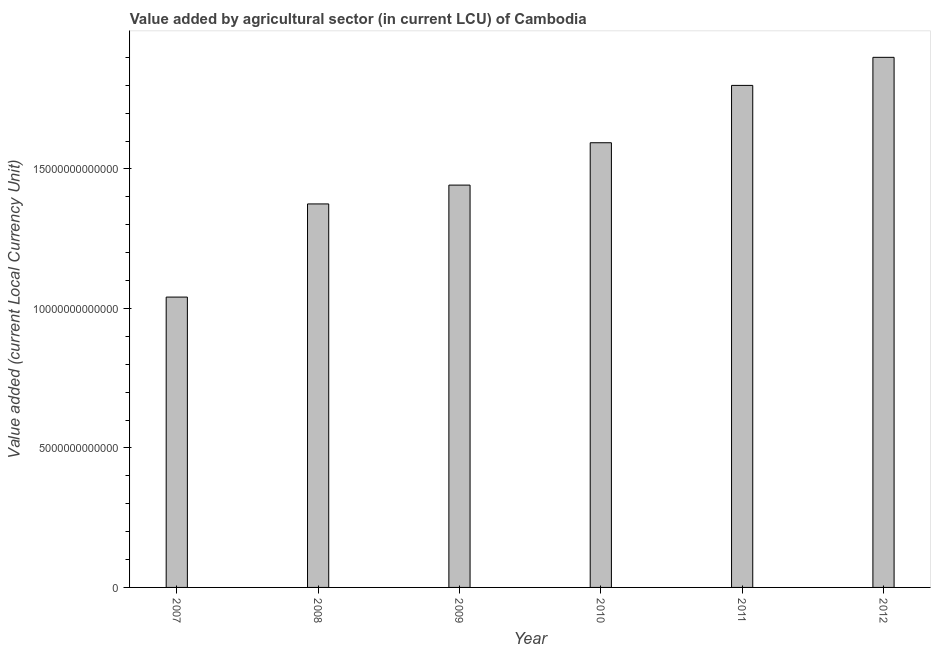Does the graph contain any zero values?
Your response must be concise. No. What is the title of the graph?
Give a very brief answer. Value added by agricultural sector (in current LCU) of Cambodia. What is the label or title of the Y-axis?
Provide a succinct answer. Value added (current Local Currency Unit). What is the value added by agriculture sector in 2011?
Your answer should be very brief. 1.80e+13. Across all years, what is the maximum value added by agriculture sector?
Offer a terse response. 1.90e+13. Across all years, what is the minimum value added by agriculture sector?
Provide a succinct answer. 1.04e+13. In which year was the value added by agriculture sector minimum?
Your answer should be very brief. 2007. What is the sum of the value added by agriculture sector?
Keep it short and to the point. 9.15e+13. What is the difference between the value added by agriculture sector in 2010 and 2011?
Your response must be concise. -2.06e+12. What is the average value added by agriculture sector per year?
Ensure brevity in your answer.  1.53e+13. What is the median value added by agriculture sector?
Provide a succinct answer. 1.52e+13. In how many years, is the value added by agriculture sector greater than 5000000000000 LCU?
Offer a very short reply. 6. Do a majority of the years between 2009 and 2007 (inclusive) have value added by agriculture sector greater than 14000000000000 LCU?
Your response must be concise. Yes. What is the ratio of the value added by agriculture sector in 2010 to that in 2011?
Provide a short and direct response. 0.89. Is the difference between the value added by agriculture sector in 2010 and 2011 greater than the difference between any two years?
Offer a very short reply. No. What is the difference between the highest and the second highest value added by agriculture sector?
Offer a terse response. 1.01e+12. What is the difference between the highest and the lowest value added by agriculture sector?
Your answer should be compact. 8.59e+12. How many bars are there?
Provide a short and direct response. 6. What is the difference between two consecutive major ticks on the Y-axis?
Provide a succinct answer. 5.00e+12. What is the Value added (current Local Currency Unit) of 2007?
Provide a short and direct response. 1.04e+13. What is the Value added (current Local Currency Unit) of 2008?
Keep it short and to the point. 1.37e+13. What is the Value added (current Local Currency Unit) in 2009?
Provide a short and direct response. 1.44e+13. What is the Value added (current Local Currency Unit) in 2010?
Your answer should be compact. 1.59e+13. What is the Value added (current Local Currency Unit) in 2011?
Provide a short and direct response. 1.80e+13. What is the Value added (current Local Currency Unit) in 2012?
Ensure brevity in your answer.  1.90e+13. What is the difference between the Value added (current Local Currency Unit) in 2007 and 2008?
Your answer should be compact. -3.34e+12. What is the difference between the Value added (current Local Currency Unit) in 2007 and 2009?
Provide a succinct answer. -4.01e+12. What is the difference between the Value added (current Local Currency Unit) in 2007 and 2010?
Keep it short and to the point. -5.53e+12. What is the difference between the Value added (current Local Currency Unit) in 2007 and 2011?
Make the answer very short. -7.59e+12. What is the difference between the Value added (current Local Currency Unit) in 2007 and 2012?
Your answer should be very brief. -8.59e+12. What is the difference between the Value added (current Local Currency Unit) in 2008 and 2009?
Offer a terse response. -6.75e+11. What is the difference between the Value added (current Local Currency Unit) in 2008 and 2010?
Keep it short and to the point. -2.19e+12. What is the difference between the Value added (current Local Currency Unit) in 2008 and 2011?
Keep it short and to the point. -4.25e+12. What is the difference between the Value added (current Local Currency Unit) in 2008 and 2012?
Your answer should be compact. -5.25e+12. What is the difference between the Value added (current Local Currency Unit) in 2009 and 2010?
Provide a short and direct response. -1.52e+12. What is the difference between the Value added (current Local Currency Unit) in 2009 and 2011?
Provide a short and direct response. -3.57e+12. What is the difference between the Value added (current Local Currency Unit) in 2009 and 2012?
Offer a terse response. -4.58e+12. What is the difference between the Value added (current Local Currency Unit) in 2010 and 2011?
Give a very brief answer. -2.06e+12. What is the difference between the Value added (current Local Currency Unit) in 2010 and 2012?
Your answer should be very brief. -3.06e+12. What is the difference between the Value added (current Local Currency Unit) in 2011 and 2012?
Give a very brief answer. -1.01e+12. What is the ratio of the Value added (current Local Currency Unit) in 2007 to that in 2008?
Keep it short and to the point. 0.76. What is the ratio of the Value added (current Local Currency Unit) in 2007 to that in 2009?
Provide a short and direct response. 0.72. What is the ratio of the Value added (current Local Currency Unit) in 2007 to that in 2010?
Your answer should be compact. 0.65. What is the ratio of the Value added (current Local Currency Unit) in 2007 to that in 2011?
Keep it short and to the point. 0.58. What is the ratio of the Value added (current Local Currency Unit) in 2007 to that in 2012?
Make the answer very short. 0.55. What is the ratio of the Value added (current Local Currency Unit) in 2008 to that in 2009?
Provide a short and direct response. 0.95. What is the ratio of the Value added (current Local Currency Unit) in 2008 to that in 2010?
Provide a succinct answer. 0.86. What is the ratio of the Value added (current Local Currency Unit) in 2008 to that in 2011?
Keep it short and to the point. 0.76. What is the ratio of the Value added (current Local Currency Unit) in 2008 to that in 2012?
Offer a terse response. 0.72. What is the ratio of the Value added (current Local Currency Unit) in 2009 to that in 2010?
Ensure brevity in your answer.  0.91. What is the ratio of the Value added (current Local Currency Unit) in 2009 to that in 2011?
Your answer should be very brief. 0.8. What is the ratio of the Value added (current Local Currency Unit) in 2009 to that in 2012?
Ensure brevity in your answer.  0.76. What is the ratio of the Value added (current Local Currency Unit) in 2010 to that in 2011?
Give a very brief answer. 0.89. What is the ratio of the Value added (current Local Currency Unit) in 2010 to that in 2012?
Provide a short and direct response. 0.84. What is the ratio of the Value added (current Local Currency Unit) in 2011 to that in 2012?
Give a very brief answer. 0.95. 